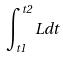Convert formula to latex. <formula><loc_0><loc_0><loc_500><loc_500>\int _ { t 1 } ^ { t 2 } L d t</formula> 